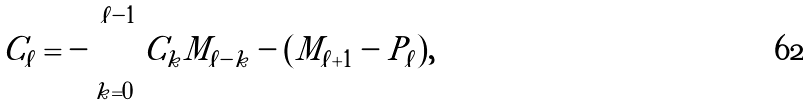Convert formula to latex. <formula><loc_0><loc_0><loc_500><loc_500>C _ { \ell } = - \sum _ { k = 0 } ^ { \ell - 1 } C _ { k } M _ { \ell - k } - ( M _ { \ell + 1 } - P _ { \ell } ) ,</formula> 